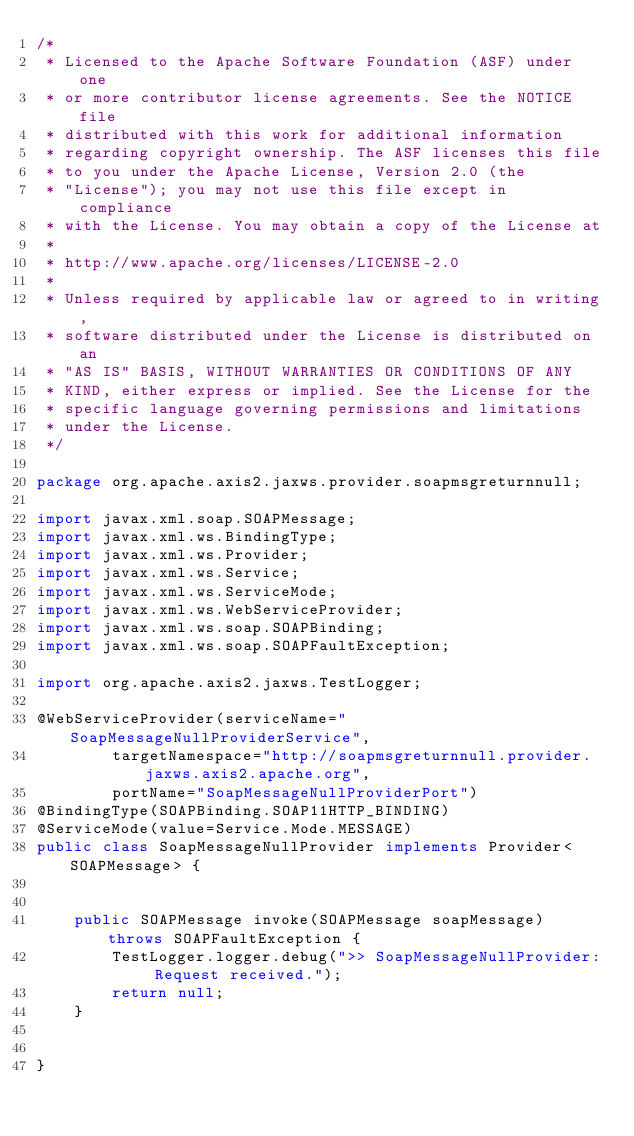<code> <loc_0><loc_0><loc_500><loc_500><_Java_>/*
 * Licensed to the Apache Software Foundation (ASF) under one
 * or more contributor license agreements. See the NOTICE file
 * distributed with this work for additional information
 * regarding copyright ownership. The ASF licenses this file
 * to you under the Apache License, Version 2.0 (the
 * "License"); you may not use this file except in compliance
 * with the License. You may obtain a copy of the License at
 *
 * http://www.apache.org/licenses/LICENSE-2.0
 *
 * Unless required by applicable law or agreed to in writing,
 * software distributed under the License is distributed on an
 * "AS IS" BASIS, WITHOUT WARRANTIES OR CONDITIONS OF ANY
 * KIND, either express or implied. See the License for the
 * specific language governing permissions and limitations
 * under the License.
 */

package org.apache.axis2.jaxws.provider.soapmsgreturnnull;

import javax.xml.soap.SOAPMessage;
import javax.xml.ws.BindingType;
import javax.xml.ws.Provider;
import javax.xml.ws.Service;
import javax.xml.ws.ServiceMode;
import javax.xml.ws.WebServiceProvider;
import javax.xml.ws.soap.SOAPBinding;
import javax.xml.ws.soap.SOAPFaultException;

import org.apache.axis2.jaxws.TestLogger;

@WebServiceProvider(serviceName="SoapMessageNullProviderService",
		targetNamespace="http://soapmsgreturnnull.provider.jaxws.axis2.apache.org",
		portName="SoapMessageNullProviderPort")
@BindingType(SOAPBinding.SOAP11HTTP_BINDING)
@ServiceMode(value=Service.Mode.MESSAGE)
public class SoapMessageNullProvider implements Provider<SOAPMessage> {
      
    
    public SOAPMessage invoke(SOAPMessage soapMessage) throws SOAPFaultException {
        TestLogger.logger.debug(">> SoapMessageNullProvider: Request received.");
        return null;
    }
    

}
</code> 